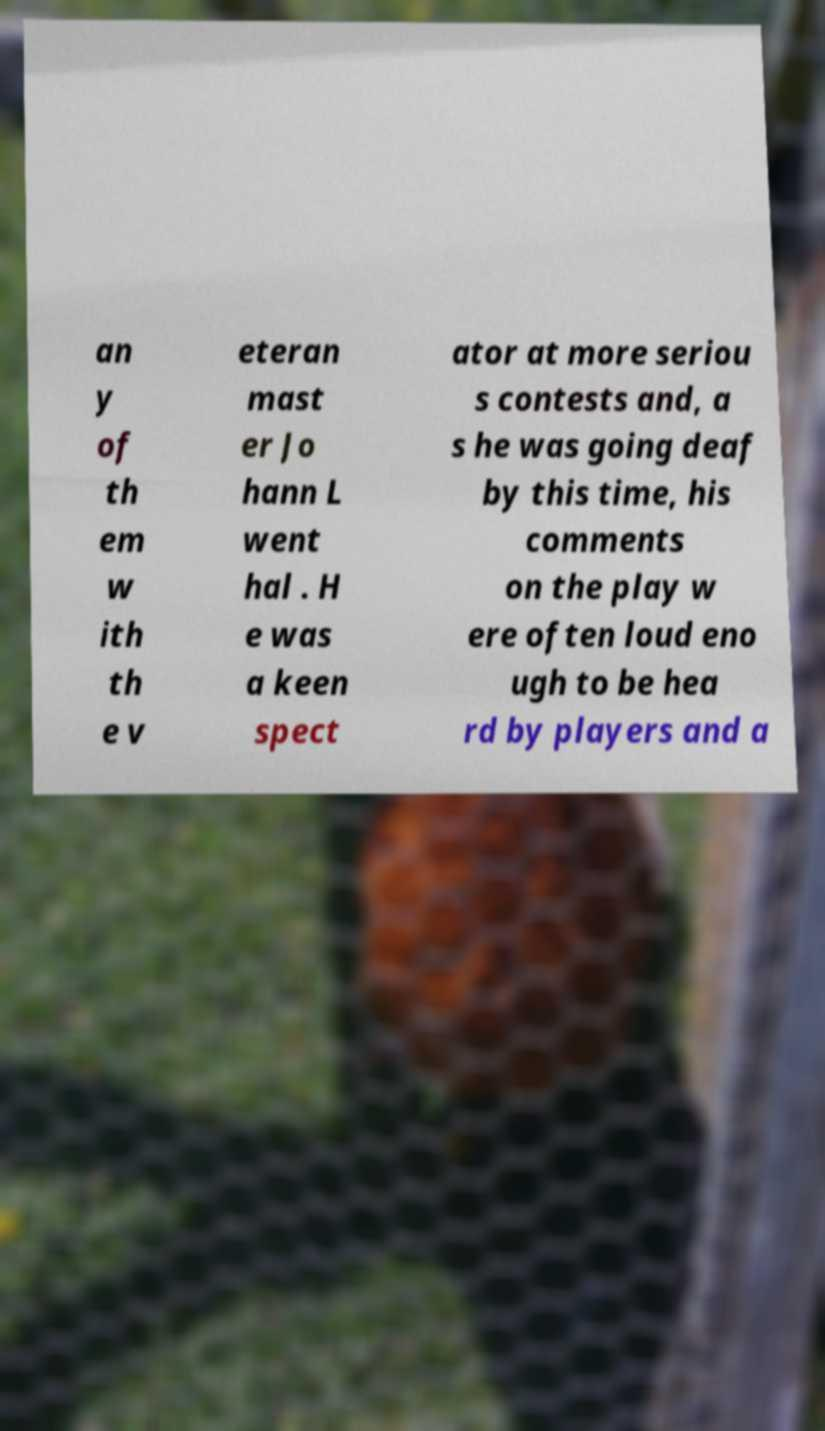There's text embedded in this image that I need extracted. Can you transcribe it verbatim? an y of th em w ith th e v eteran mast er Jo hann L went hal . H e was a keen spect ator at more seriou s contests and, a s he was going deaf by this time, his comments on the play w ere often loud eno ugh to be hea rd by players and a 